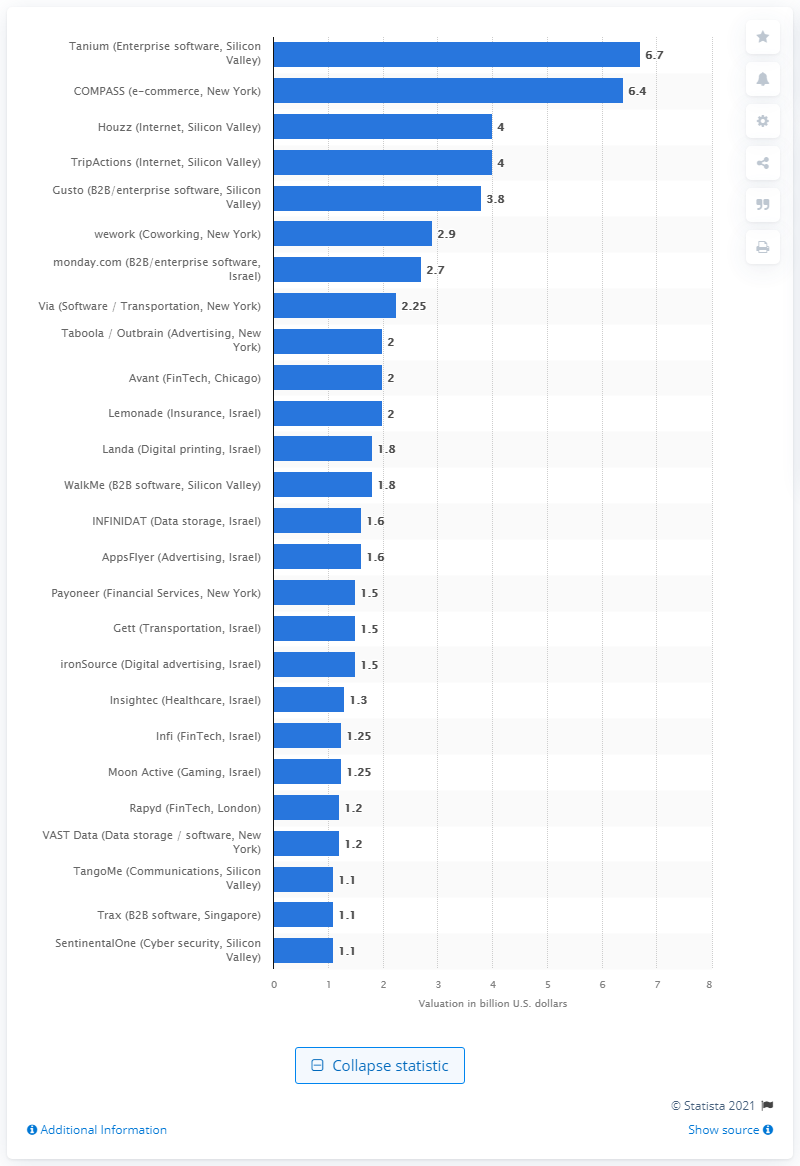Indicate a few pertinent items in this graphic. In 2020, the valuation of Lemonade was two. 